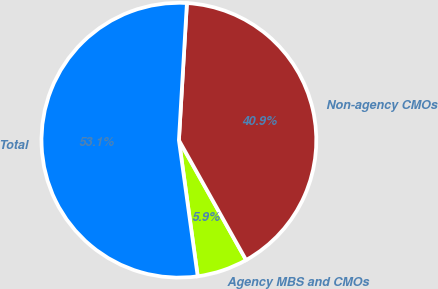<chart> <loc_0><loc_0><loc_500><loc_500><pie_chart><fcel>Agency MBS and CMOs<fcel>Non-agency CMOs<fcel>Total<nl><fcel>5.95%<fcel>40.94%<fcel>53.12%<nl></chart> 